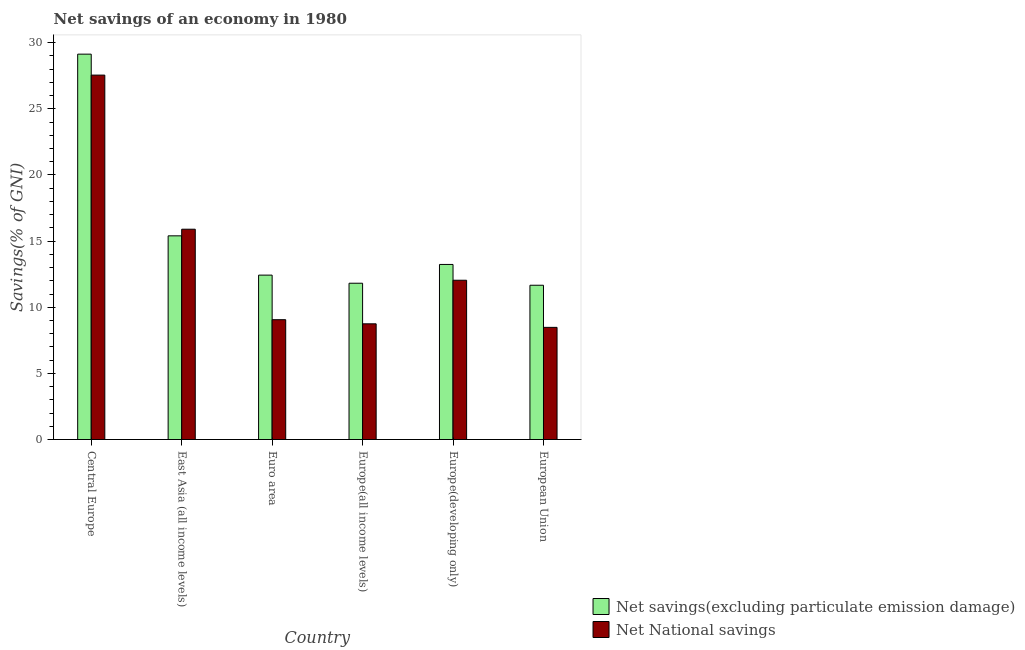How many different coloured bars are there?
Your response must be concise. 2. Are the number of bars on each tick of the X-axis equal?
Offer a terse response. Yes. How many bars are there on the 1st tick from the right?
Ensure brevity in your answer.  2. What is the label of the 6th group of bars from the left?
Make the answer very short. European Union. What is the net national savings in East Asia (all income levels)?
Offer a very short reply. 15.9. Across all countries, what is the maximum net savings(excluding particulate emission damage)?
Give a very brief answer. 29.13. Across all countries, what is the minimum net savings(excluding particulate emission damage)?
Your answer should be compact. 11.66. In which country was the net national savings maximum?
Make the answer very short. Central Europe. What is the total net national savings in the graph?
Keep it short and to the point. 81.77. What is the difference between the net savings(excluding particulate emission damage) in Central Europe and that in European Union?
Your answer should be compact. 17.47. What is the difference between the net national savings in Europe(all income levels) and the net savings(excluding particulate emission damage) in Europe(developing only)?
Give a very brief answer. -4.49. What is the average net national savings per country?
Keep it short and to the point. 13.63. What is the difference between the net savings(excluding particulate emission damage) and net national savings in East Asia (all income levels)?
Provide a succinct answer. -0.5. What is the ratio of the net savings(excluding particulate emission damage) in Europe(all income levels) to that in Europe(developing only)?
Ensure brevity in your answer.  0.89. Is the net savings(excluding particulate emission damage) in Europe(developing only) less than that in European Union?
Your response must be concise. No. Is the difference between the net savings(excluding particulate emission damage) in East Asia (all income levels) and Euro area greater than the difference between the net national savings in East Asia (all income levels) and Euro area?
Provide a succinct answer. No. What is the difference between the highest and the second highest net national savings?
Your answer should be compact. 11.65. What is the difference between the highest and the lowest net national savings?
Your response must be concise. 19.07. In how many countries, is the net national savings greater than the average net national savings taken over all countries?
Your answer should be compact. 2. Is the sum of the net national savings in Euro area and Europe(developing only) greater than the maximum net savings(excluding particulate emission damage) across all countries?
Offer a very short reply. No. What does the 1st bar from the left in Central Europe represents?
Offer a very short reply. Net savings(excluding particulate emission damage). What does the 2nd bar from the right in Central Europe represents?
Offer a terse response. Net savings(excluding particulate emission damage). How many bars are there?
Your answer should be compact. 12. Are all the bars in the graph horizontal?
Offer a terse response. No. Does the graph contain any zero values?
Offer a very short reply. No. Does the graph contain grids?
Offer a very short reply. No. How many legend labels are there?
Give a very brief answer. 2. What is the title of the graph?
Provide a succinct answer. Net savings of an economy in 1980. What is the label or title of the X-axis?
Ensure brevity in your answer.  Country. What is the label or title of the Y-axis?
Make the answer very short. Savings(% of GNI). What is the Savings(% of GNI) in Net savings(excluding particulate emission damage) in Central Europe?
Your answer should be very brief. 29.13. What is the Savings(% of GNI) of Net National savings in Central Europe?
Provide a short and direct response. 27.55. What is the Savings(% of GNI) in Net savings(excluding particulate emission damage) in East Asia (all income levels)?
Give a very brief answer. 15.4. What is the Savings(% of GNI) of Net National savings in East Asia (all income levels)?
Provide a short and direct response. 15.9. What is the Savings(% of GNI) of Net savings(excluding particulate emission damage) in Euro area?
Offer a very short reply. 12.43. What is the Savings(% of GNI) of Net National savings in Euro area?
Ensure brevity in your answer.  9.06. What is the Savings(% of GNI) of Net savings(excluding particulate emission damage) in Europe(all income levels)?
Provide a short and direct response. 11.82. What is the Savings(% of GNI) of Net National savings in Europe(all income levels)?
Provide a short and direct response. 8.75. What is the Savings(% of GNI) of Net savings(excluding particulate emission damage) in Europe(developing only)?
Make the answer very short. 13.24. What is the Savings(% of GNI) in Net National savings in Europe(developing only)?
Keep it short and to the point. 12.04. What is the Savings(% of GNI) of Net savings(excluding particulate emission damage) in European Union?
Provide a short and direct response. 11.66. What is the Savings(% of GNI) in Net National savings in European Union?
Give a very brief answer. 8.48. Across all countries, what is the maximum Savings(% of GNI) of Net savings(excluding particulate emission damage)?
Offer a terse response. 29.13. Across all countries, what is the maximum Savings(% of GNI) in Net National savings?
Make the answer very short. 27.55. Across all countries, what is the minimum Savings(% of GNI) of Net savings(excluding particulate emission damage)?
Provide a succinct answer. 11.66. Across all countries, what is the minimum Savings(% of GNI) in Net National savings?
Ensure brevity in your answer.  8.48. What is the total Savings(% of GNI) in Net savings(excluding particulate emission damage) in the graph?
Offer a very short reply. 93.67. What is the total Savings(% of GNI) of Net National savings in the graph?
Offer a terse response. 81.77. What is the difference between the Savings(% of GNI) in Net savings(excluding particulate emission damage) in Central Europe and that in East Asia (all income levels)?
Provide a short and direct response. 13.74. What is the difference between the Savings(% of GNI) in Net National savings in Central Europe and that in East Asia (all income levels)?
Offer a terse response. 11.65. What is the difference between the Savings(% of GNI) in Net savings(excluding particulate emission damage) in Central Europe and that in Euro area?
Make the answer very short. 16.71. What is the difference between the Savings(% of GNI) in Net National savings in Central Europe and that in Euro area?
Offer a very short reply. 18.49. What is the difference between the Savings(% of GNI) in Net savings(excluding particulate emission damage) in Central Europe and that in Europe(all income levels)?
Offer a terse response. 17.32. What is the difference between the Savings(% of GNI) in Net National savings in Central Europe and that in Europe(all income levels)?
Your answer should be very brief. 18.8. What is the difference between the Savings(% of GNI) in Net savings(excluding particulate emission damage) in Central Europe and that in Europe(developing only)?
Offer a very short reply. 15.9. What is the difference between the Savings(% of GNI) of Net National savings in Central Europe and that in Europe(developing only)?
Keep it short and to the point. 15.51. What is the difference between the Savings(% of GNI) of Net savings(excluding particulate emission damage) in Central Europe and that in European Union?
Keep it short and to the point. 17.47. What is the difference between the Savings(% of GNI) in Net National savings in Central Europe and that in European Union?
Keep it short and to the point. 19.07. What is the difference between the Savings(% of GNI) of Net savings(excluding particulate emission damage) in East Asia (all income levels) and that in Euro area?
Make the answer very short. 2.97. What is the difference between the Savings(% of GNI) of Net National savings in East Asia (all income levels) and that in Euro area?
Offer a terse response. 6.84. What is the difference between the Savings(% of GNI) of Net savings(excluding particulate emission damage) in East Asia (all income levels) and that in Europe(all income levels)?
Ensure brevity in your answer.  3.58. What is the difference between the Savings(% of GNI) of Net National savings in East Asia (all income levels) and that in Europe(all income levels)?
Provide a succinct answer. 7.15. What is the difference between the Savings(% of GNI) in Net savings(excluding particulate emission damage) in East Asia (all income levels) and that in Europe(developing only)?
Offer a terse response. 2.16. What is the difference between the Savings(% of GNI) in Net National savings in East Asia (all income levels) and that in Europe(developing only)?
Your response must be concise. 3.86. What is the difference between the Savings(% of GNI) of Net savings(excluding particulate emission damage) in East Asia (all income levels) and that in European Union?
Provide a succinct answer. 3.74. What is the difference between the Savings(% of GNI) in Net National savings in East Asia (all income levels) and that in European Union?
Your answer should be compact. 7.42. What is the difference between the Savings(% of GNI) in Net savings(excluding particulate emission damage) in Euro area and that in Europe(all income levels)?
Offer a very short reply. 0.61. What is the difference between the Savings(% of GNI) of Net National savings in Euro area and that in Europe(all income levels)?
Give a very brief answer. 0.31. What is the difference between the Savings(% of GNI) of Net savings(excluding particulate emission damage) in Euro area and that in Europe(developing only)?
Offer a very short reply. -0.81. What is the difference between the Savings(% of GNI) in Net National savings in Euro area and that in Europe(developing only)?
Make the answer very short. -2.98. What is the difference between the Savings(% of GNI) in Net savings(excluding particulate emission damage) in Euro area and that in European Union?
Keep it short and to the point. 0.77. What is the difference between the Savings(% of GNI) in Net National savings in Euro area and that in European Union?
Provide a succinct answer. 0.58. What is the difference between the Savings(% of GNI) in Net savings(excluding particulate emission damage) in Europe(all income levels) and that in Europe(developing only)?
Your answer should be compact. -1.42. What is the difference between the Savings(% of GNI) of Net National savings in Europe(all income levels) and that in Europe(developing only)?
Make the answer very short. -3.29. What is the difference between the Savings(% of GNI) of Net savings(excluding particulate emission damage) in Europe(all income levels) and that in European Union?
Give a very brief answer. 0.15. What is the difference between the Savings(% of GNI) in Net National savings in Europe(all income levels) and that in European Union?
Offer a very short reply. 0.27. What is the difference between the Savings(% of GNI) in Net savings(excluding particulate emission damage) in Europe(developing only) and that in European Union?
Ensure brevity in your answer.  1.57. What is the difference between the Savings(% of GNI) of Net National savings in Europe(developing only) and that in European Union?
Your answer should be very brief. 3.56. What is the difference between the Savings(% of GNI) of Net savings(excluding particulate emission damage) in Central Europe and the Savings(% of GNI) of Net National savings in East Asia (all income levels)?
Give a very brief answer. 13.23. What is the difference between the Savings(% of GNI) of Net savings(excluding particulate emission damage) in Central Europe and the Savings(% of GNI) of Net National savings in Euro area?
Keep it short and to the point. 20.08. What is the difference between the Savings(% of GNI) of Net savings(excluding particulate emission damage) in Central Europe and the Savings(% of GNI) of Net National savings in Europe(all income levels)?
Ensure brevity in your answer.  20.39. What is the difference between the Savings(% of GNI) of Net savings(excluding particulate emission damage) in Central Europe and the Savings(% of GNI) of Net National savings in Europe(developing only)?
Provide a short and direct response. 17.09. What is the difference between the Savings(% of GNI) of Net savings(excluding particulate emission damage) in Central Europe and the Savings(% of GNI) of Net National savings in European Union?
Your answer should be very brief. 20.66. What is the difference between the Savings(% of GNI) of Net savings(excluding particulate emission damage) in East Asia (all income levels) and the Savings(% of GNI) of Net National savings in Euro area?
Your response must be concise. 6.34. What is the difference between the Savings(% of GNI) in Net savings(excluding particulate emission damage) in East Asia (all income levels) and the Savings(% of GNI) in Net National savings in Europe(all income levels)?
Offer a very short reply. 6.65. What is the difference between the Savings(% of GNI) in Net savings(excluding particulate emission damage) in East Asia (all income levels) and the Savings(% of GNI) in Net National savings in Europe(developing only)?
Provide a succinct answer. 3.36. What is the difference between the Savings(% of GNI) of Net savings(excluding particulate emission damage) in East Asia (all income levels) and the Savings(% of GNI) of Net National savings in European Union?
Your response must be concise. 6.92. What is the difference between the Savings(% of GNI) of Net savings(excluding particulate emission damage) in Euro area and the Savings(% of GNI) of Net National savings in Europe(all income levels)?
Give a very brief answer. 3.68. What is the difference between the Savings(% of GNI) in Net savings(excluding particulate emission damage) in Euro area and the Savings(% of GNI) in Net National savings in Europe(developing only)?
Provide a short and direct response. 0.39. What is the difference between the Savings(% of GNI) of Net savings(excluding particulate emission damage) in Euro area and the Savings(% of GNI) of Net National savings in European Union?
Provide a short and direct response. 3.95. What is the difference between the Savings(% of GNI) in Net savings(excluding particulate emission damage) in Europe(all income levels) and the Savings(% of GNI) in Net National savings in Europe(developing only)?
Keep it short and to the point. -0.23. What is the difference between the Savings(% of GNI) of Net savings(excluding particulate emission damage) in Europe(all income levels) and the Savings(% of GNI) of Net National savings in European Union?
Give a very brief answer. 3.34. What is the difference between the Savings(% of GNI) in Net savings(excluding particulate emission damage) in Europe(developing only) and the Savings(% of GNI) in Net National savings in European Union?
Ensure brevity in your answer.  4.76. What is the average Savings(% of GNI) of Net savings(excluding particulate emission damage) per country?
Your response must be concise. 15.61. What is the average Savings(% of GNI) of Net National savings per country?
Offer a terse response. 13.63. What is the difference between the Savings(% of GNI) in Net savings(excluding particulate emission damage) and Savings(% of GNI) in Net National savings in Central Europe?
Offer a terse response. 1.58. What is the difference between the Savings(% of GNI) in Net savings(excluding particulate emission damage) and Savings(% of GNI) in Net National savings in East Asia (all income levels)?
Give a very brief answer. -0.5. What is the difference between the Savings(% of GNI) of Net savings(excluding particulate emission damage) and Savings(% of GNI) of Net National savings in Euro area?
Give a very brief answer. 3.37. What is the difference between the Savings(% of GNI) of Net savings(excluding particulate emission damage) and Savings(% of GNI) of Net National savings in Europe(all income levels)?
Give a very brief answer. 3.07. What is the difference between the Savings(% of GNI) of Net savings(excluding particulate emission damage) and Savings(% of GNI) of Net National savings in Europe(developing only)?
Your response must be concise. 1.2. What is the difference between the Savings(% of GNI) in Net savings(excluding particulate emission damage) and Savings(% of GNI) in Net National savings in European Union?
Make the answer very short. 3.18. What is the ratio of the Savings(% of GNI) in Net savings(excluding particulate emission damage) in Central Europe to that in East Asia (all income levels)?
Give a very brief answer. 1.89. What is the ratio of the Savings(% of GNI) in Net National savings in Central Europe to that in East Asia (all income levels)?
Offer a very short reply. 1.73. What is the ratio of the Savings(% of GNI) of Net savings(excluding particulate emission damage) in Central Europe to that in Euro area?
Make the answer very short. 2.34. What is the ratio of the Savings(% of GNI) in Net National savings in Central Europe to that in Euro area?
Offer a very short reply. 3.04. What is the ratio of the Savings(% of GNI) of Net savings(excluding particulate emission damage) in Central Europe to that in Europe(all income levels)?
Make the answer very short. 2.47. What is the ratio of the Savings(% of GNI) of Net National savings in Central Europe to that in Europe(all income levels)?
Your response must be concise. 3.15. What is the ratio of the Savings(% of GNI) in Net savings(excluding particulate emission damage) in Central Europe to that in Europe(developing only)?
Offer a terse response. 2.2. What is the ratio of the Savings(% of GNI) of Net National savings in Central Europe to that in Europe(developing only)?
Your response must be concise. 2.29. What is the ratio of the Savings(% of GNI) in Net savings(excluding particulate emission damage) in Central Europe to that in European Union?
Ensure brevity in your answer.  2.5. What is the ratio of the Savings(% of GNI) in Net National savings in Central Europe to that in European Union?
Your response must be concise. 3.25. What is the ratio of the Savings(% of GNI) of Net savings(excluding particulate emission damage) in East Asia (all income levels) to that in Euro area?
Keep it short and to the point. 1.24. What is the ratio of the Savings(% of GNI) in Net National savings in East Asia (all income levels) to that in Euro area?
Provide a succinct answer. 1.76. What is the ratio of the Savings(% of GNI) of Net savings(excluding particulate emission damage) in East Asia (all income levels) to that in Europe(all income levels)?
Give a very brief answer. 1.3. What is the ratio of the Savings(% of GNI) in Net National savings in East Asia (all income levels) to that in Europe(all income levels)?
Provide a short and direct response. 1.82. What is the ratio of the Savings(% of GNI) in Net savings(excluding particulate emission damage) in East Asia (all income levels) to that in Europe(developing only)?
Your answer should be very brief. 1.16. What is the ratio of the Savings(% of GNI) of Net National savings in East Asia (all income levels) to that in Europe(developing only)?
Offer a terse response. 1.32. What is the ratio of the Savings(% of GNI) of Net savings(excluding particulate emission damage) in East Asia (all income levels) to that in European Union?
Provide a short and direct response. 1.32. What is the ratio of the Savings(% of GNI) of Net National savings in East Asia (all income levels) to that in European Union?
Your answer should be compact. 1.88. What is the ratio of the Savings(% of GNI) of Net savings(excluding particulate emission damage) in Euro area to that in Europe(all income levels)?
Your answer should be compact. 1.05. What is the ratio of the Savings(% of GNI) of Net National savings in Euro area to that in Europe(all income levels)?
Ensure brevity in your answer.  1.04. What is the ratio of the Savings(% of GNI) of Net savings(excluding particulate emission damage) in Euro area to that in Europe(developing only)?
Offer a terse response. 0.94. What is the ratio of the Savings(% of GNI) in Net National savings in Euro area to that in Europe(developing only)?
Provide a succinct answer. 0.75. What is the ratio of the Savings(% of GNI) in Net savings(excluding particulate emission damage) in Euro area to that in European Union?
Make the answer very short. 1.07. What is the ratio of the Savings(% of GNI) of Net National savings in Euro area to that in European Union?
Offer a very short reply. 1.07. What is the ratio of the Savings(% of GNI) of Net savings(excluding particulate emission damage) in Europe(all income levels) to that in Europe(developing only)?
Make the answer very short. 0.89. What is the ratio of the Savings(% of GNI) in Net National savings in Europe(all income levels) to that in Europe(developing only)?
Your answer should be very brief. 0.73. What is the ratio of the Savings(% of GNI) in Net savings(excluding particulate emission damage) in Europe(all income levels) to that in European Union?
Ensure brevity in your answer.  1.01. What is the ratio of the Savings(% of GNI) in Net National savings in Europe(all income levels) to that in European Union?
Provide a short and direct response. 1.03. What is the ratio of the Savings(% of GNI) of Net savings(excluding particulate emission damage) in Europe(developing only) to that in European Union?
Provide a succinct answer. 1.13. What is the ratio of the Savings(% of GNI) of Net National savings in Europe(developing only) to that in European Union?
Provide a succinct answer. 1.42. What is the difference between the highest and the second highest Savings(% of GNI) in Net savings(excluding particulate emission damage)?
Your answer should be very brief. 13.74. What is the difference between the highest and the second highest Savings(% of GNI) in Net National savings?
Provide a short and direct response. 11.65. What is the difference between the highest and the lowest Savings(% of GNI) of Net savings(excluding particulate emission damage)?
Your answer should be compact. 17.47. What is the difference between the highest and the lowest Savings(% of GNI) of Net National savings?
Your answer should be very brief. 19.07. 